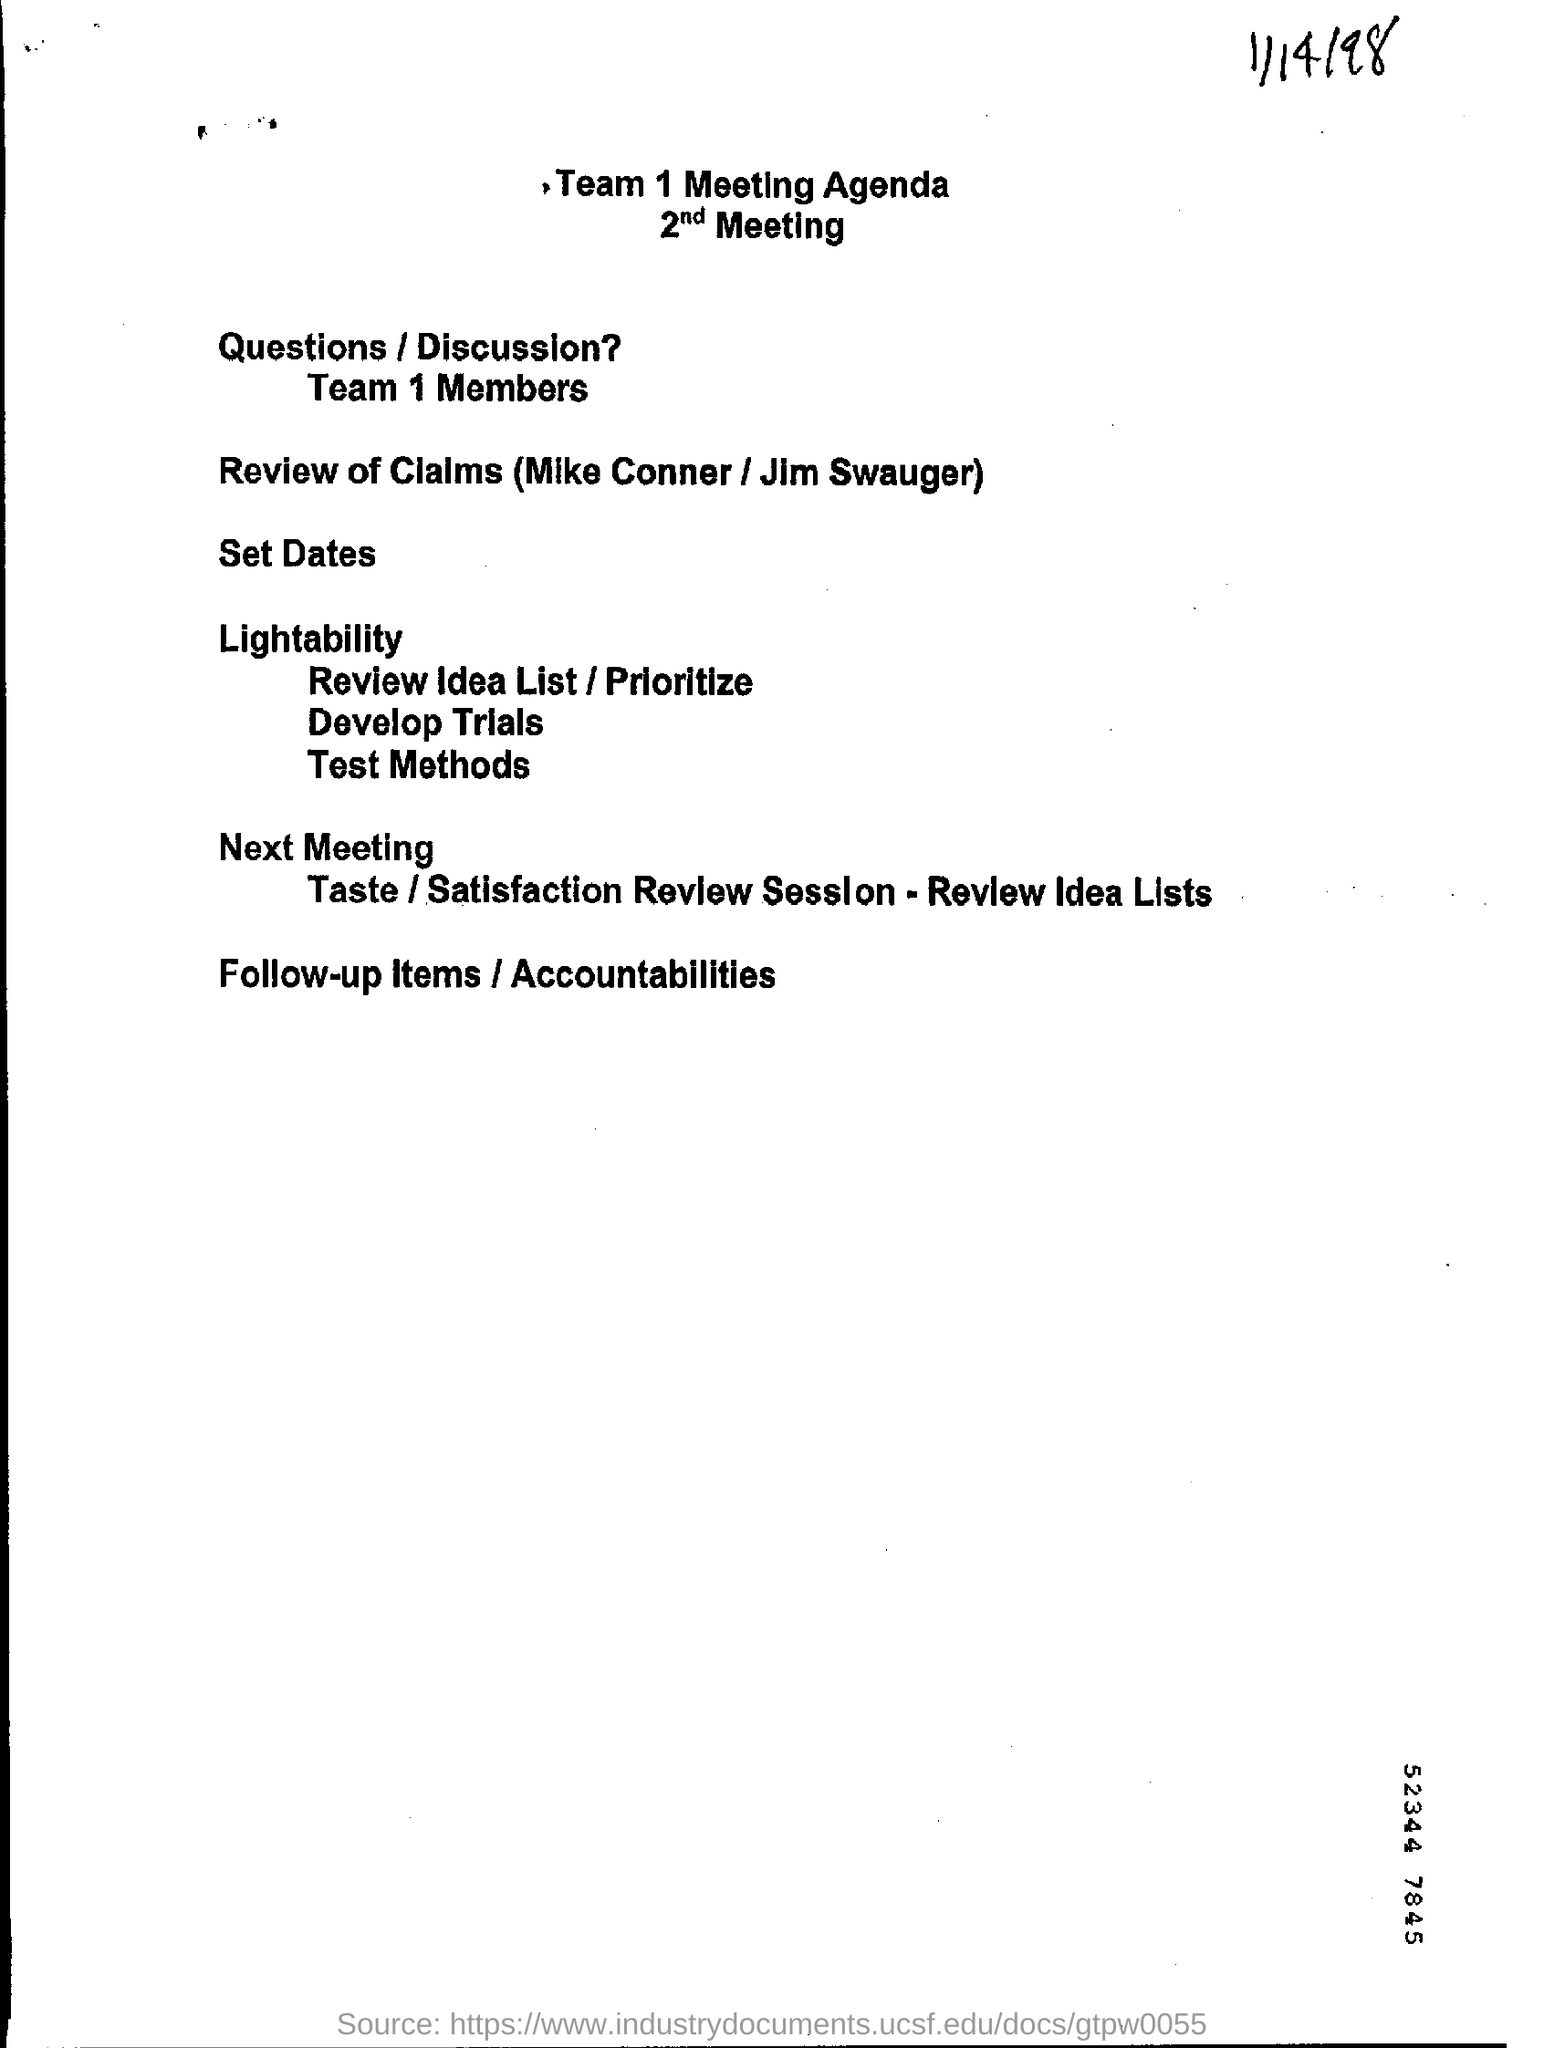Mention the date at top right corner of the page ?
Make the answer very short. 1/14/98. 